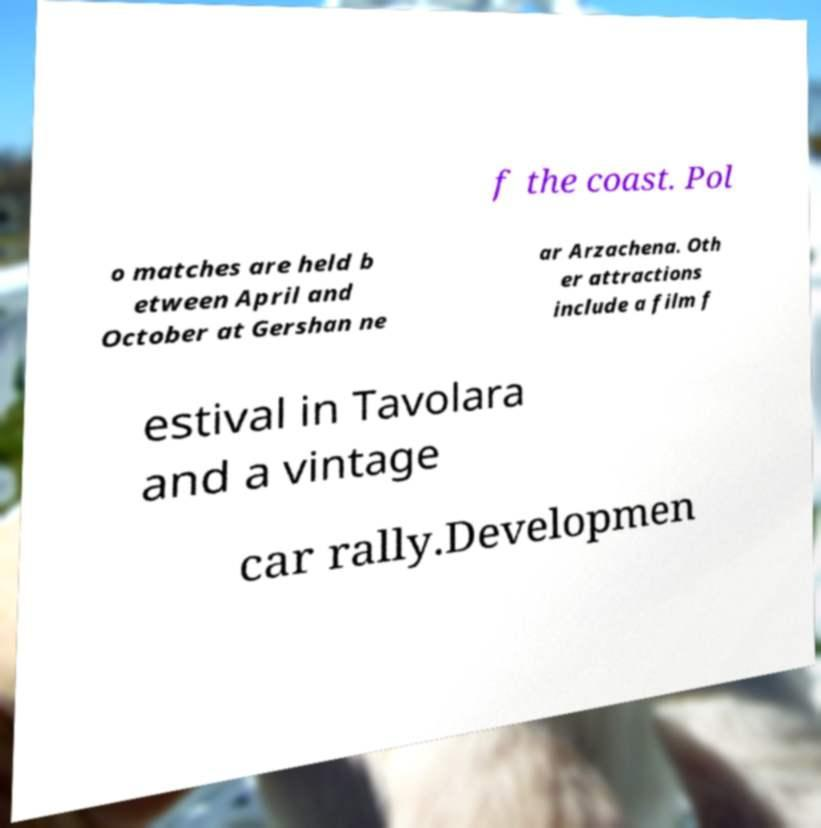For documentation purposes, I need the text within this image transcribed. Could you provide that? f the coast. Pol o matches are held b etween April and October at Gershan ne ar Arzachena. Oth er attractions include a film f estival in Tavolara and a vintage car rally.Developmen 